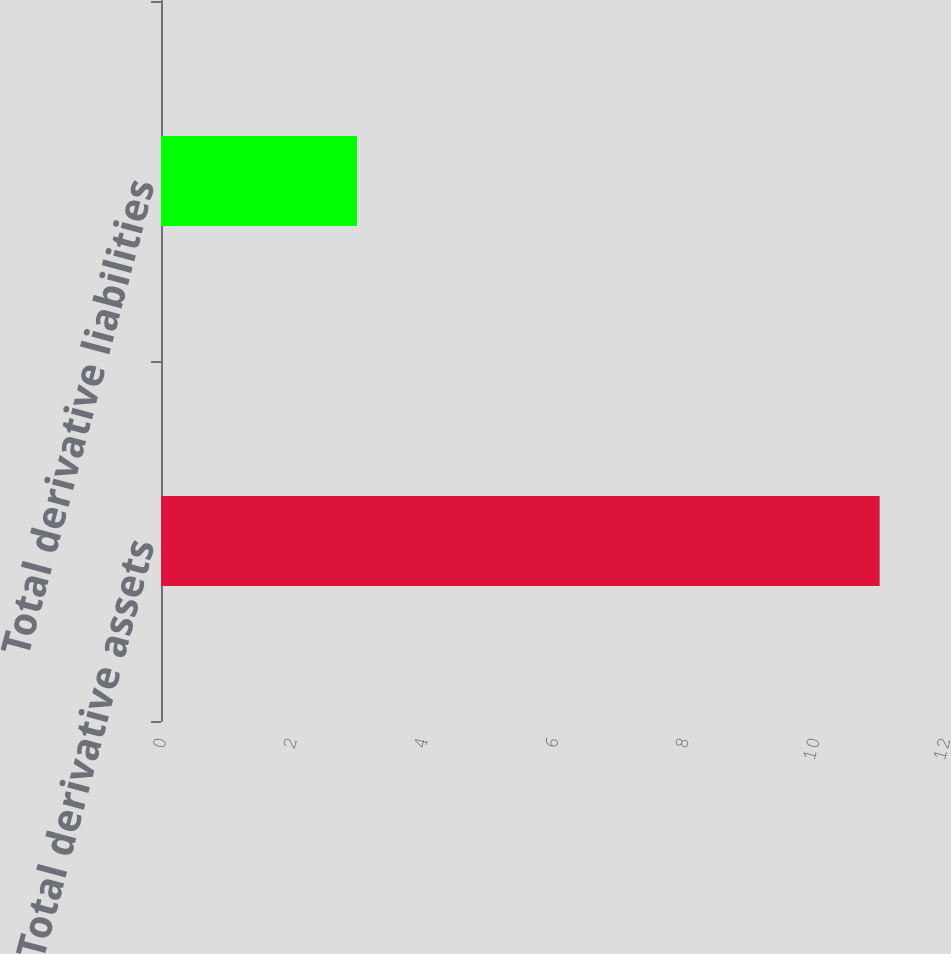Convert chart. <chart><loc_0><loc_0><loc_500><loc_500><bar_chart><fcel>Total derivative assets<fcel>Total derivative liabilities<nl><fcel>11<fcel>3<nl></chart> 